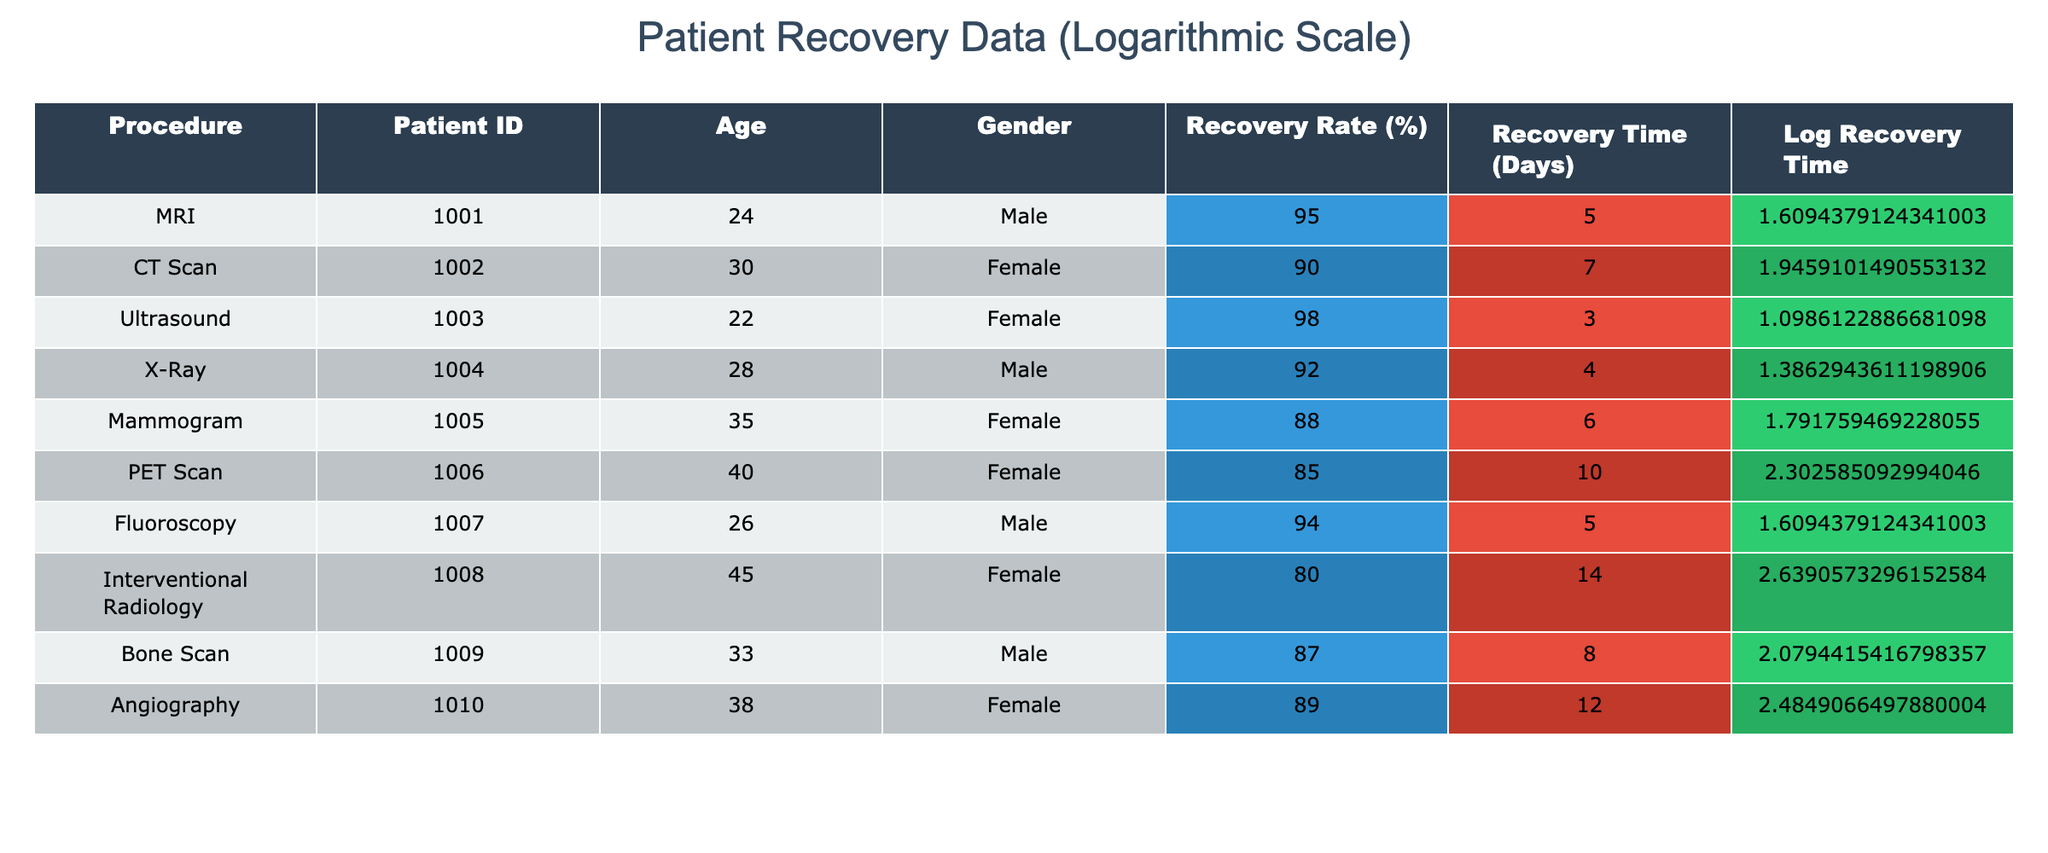What was the recovery rate for the Ultrasound procedure? The recovery rate for the Ultrasound procedure is provided in the table under the 'Recovery Rate (%)' column corresponding to the Ultrasound entry. The value is 98%.
Answer: 98% Which procedure had the longest recovery time? To determine the longest recovery time, we can look across the 'Recovery Time (Days)' column. The Interventional Radiology procedure has the highest value of 14 days.
Answer: Interventional Radiology What is the average recovery rate for male patients? The recovery rates for male patients in the table are 95% (MRI), 92% (X-Ray), 94% (Fluoroscopy), and 87% (Bone Scan). Adding these gives 368%. Dividing by the 4 male patients gives an average of 92%.
Answer: 92% Is it true that all imaging procedures listed have a recovery rate above 80%? By examining the 'Recovery Rate (%)' column, we see that the lowest recovery rate is for the PET Scan at 85%. Since all values are above 80%, the statement is true.
Answer: Yes What is the difference in recovery rates between the procedure with the highest and the lowest recovery rates? The highest recovery rate is 98% for the Ultrasound procedure, and the lowest is 80% for the Interventional Radiology. The difference is calculated as 98% - 80%, which equals 18%.
Answer: 18% Which gender had a higher average recovery rate, male or female? The recovery rates for males are 95%, 92%, 94%, and 87%, totaling 368%, with an average of 92%. The recovery rates for females are 90%, 98%, 88%, 85%, and 89%, totaling 440%, with an average of 88%. Since 92% (male) is greater than 88% (female), males had a higher average recovery rate.
Answer: Male How many procedures had a recovery rate of 90% or higher? The procedures with recovery rates of 90% or higher are MRI, Ultrasound, Fluoroscopy, and Angiography, totaling 4 procedures.
Answer: 4 What is the median recovery time among the listed procedures? To find the median recovery time, we first order the recovery times (3, 4, 5, 5, 6, 7, 8, 10, 12, 14). The median is the average of the 5th and 6th values in this ordered list, which is (6 + 7) / 2 = 6.5 days.
Answer: 6.5 days Which imaging procedure had the lowest patient age? By examining the 'Age' column, the lowest age recorded is 22 years for the Ultrasound procedure.
Answer: Ultrasound 